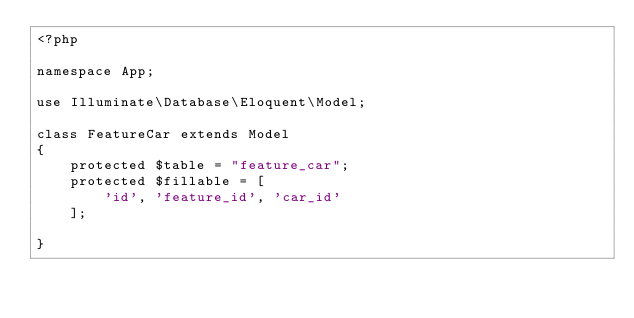Convert code to text. <code><loc_0><loc_0><loc_500><loc_500><_PHP_><?php

namespace App;

use Illuminate\Database\Eloquent\Model;

class FeatureCar extends Model
{
    protected $table = "feature_car";
    protected $fillable = [
        'id', 'feature_id', 'car_id'
    ];
    
}
</code> 